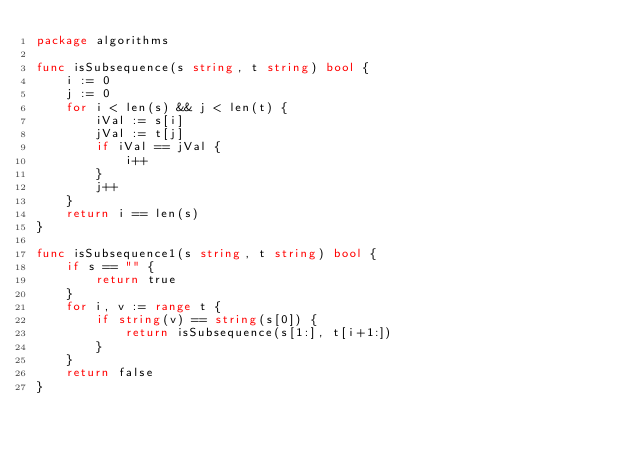<code> <loc_0><loc_0><loc_500><loc_500><_Go_>package algorithms

func isSubsequence(s string, t string) bool {
	i := 0
	j := 0
	for i < len(s) && j < len(t) {
		iVal := s[i]
		jVal := t[j]
		if iVal == jVal {
			i++
		}
		j++
	}
	return i == len(s)
}

func isSubsequence1(s string, t string) bool {
	if s == "" {
		return true
	}
	for i, v := range t {
		if string(v) == string(s[0]) {
			return isSubsequence(s[1:], t[i+1:])
		}
	}
	return false
}
</code> 